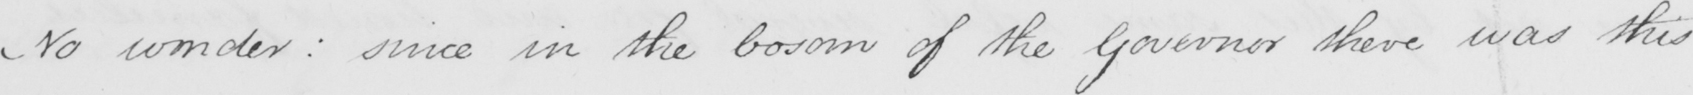Transcribe the text shown in this historical manuscript line. No wonder :  since in the bosom of the Governor there was this 